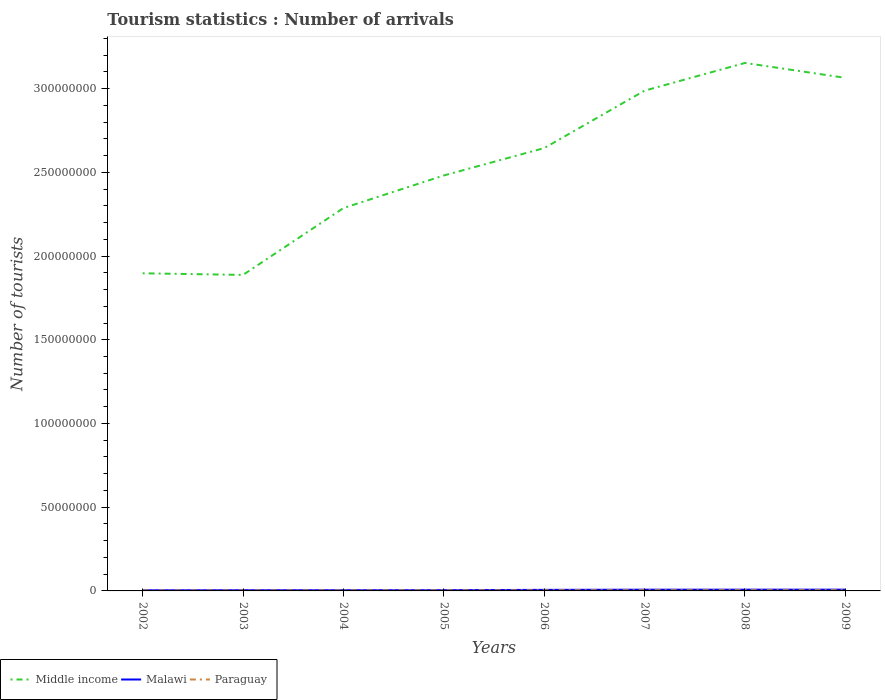Is the number of lines equal to the number of legend labels?
Keep it short and to the point. Yes. Across all years, what is the maximum number of tourist arrivals in Middle income?
Offer a very short reply. 1.89e+08. In which year was the number of tourist arrivals in Paraguay maximum?
Offer a terse response. 2002. What is the total number of tourist arrivals in Paraguay in the graph?
Offer a very short reply. -1.19e+05. What is the difference between the highest and the second highest number of tourist arrivals in Malawi?
Keep it short and to the point. 3.72e+05. What is the difference between the highest and the lowest number of tourist arrivals in Paraguay?
Keep it short and to the point. 4. How many years are there in the graph?
Keep it short and to the point. 8. What is the difference between two consecutive major ticks on the Y-axis?
Offer a terse response. 5.00e+07. Does the graph contain any zero values?
Ensure brevity in your answer.  No. Does the graph contain grids?
Give a very brief answer. No. Where does the legend appear in the graph?
Your answer should be compact. Bottom left. What is the title of the graph?
Provide a succinct answer. Tourism statistics : Number of arrivals. What is the label or title of the Y-axis?
Provide a short and direct response. Number of tourists. What is the Number of tourists in Middle income in 2002?
Your response must be concise. 1.90e+08. What is the Number of tourists of Malawi in 2002?
Make the answer very short. 3.83e+05. What is the Number of tourists of Paraguay in 2002?
Provide a short and direct response. 2.50e+05. What is the Number of tourists of Middle income in 2003?
Offer a terse response. 1.89e+08. What is the Number of tourists in Malawi in 2003?
Provide a short and direct response. 4.24e+05. What is the Number of tourists in Paraguay in 2003?
Ensure brevity in your answer.  2.68e+05. What is the Number of tourists of Middle income in 2004?
Provide a short and direct response. 2.29e+08. What is the Number of tourists of Malawi in 2004?
Keep it short and to the point. 4.27e+05. What is the Number of tourists of Paraguay in 2004?
Ensure brevity in your answer.  3.09e+05. What is the Number of tourists of Middle income in 2005?
Offer a terse response. 2.48e+08. What is the Number of tourists of Malawi in 2005?
Give a very brief answer. 4.38e+05. What is the Number of tourists in Paraguay in 2005?
Keep it short and to the point. 3.41e+05. What is the Number of tourists in Middle income in 2006?
Your answer should be compact. 2.64e+08. What is the Number of tourists of Malawi in 2006?
Provide a succinct answer. 6.38e+05. What is the Number of tourists of Paraguay in 2006?
Offer a terse response. 3.88e+05. What is the Number of tourists in Middle income in 2007?
Provide a succinct answer. 2.99e+08. What is the Number of tourists in Malawi in 2007?
Ensure brevity in your answer.  7.35e+05. What is the Number of tourists of Paraguay in 2007?
Give a very brief answer. 4.16e+05. What is the Number of tourists in Middle income in 2008?
Offer a very short reply. 3.15e+08. What is the Number of tourists of Malawi in 2008?
Keep it short and to the point. 7.42e+05. What is the Number of tourists in Paraguay in 2008?
Give a very brief answer. 4.28e+05. What is the Number of tourists of Middle income in 2009?
Your answer should be very brief. 3.06e+08. What is the Number of tourists in Malawi in 2009?
Offer a terse response. 7.55e+05. What is the Number of tourists in Paraguay in 2009?
Provide a short and direct response. 4.39e+05. Across all years, what is the maximum Number of tourists in Middle income?
Provide a succinct answer. 3.15e+08. Across all years, what is the maximum Number of tourists in Malawi?
Your response must be concise. 7.55e+05. Across all years, what is the maximum Number of tourists in Paraguay?
Your answer should be compact. 4.39e+05. Across all years, what is the minimum Number of tourists in Middle income?
Keep it short and to the point. 1.89e+08. Across all years, what is the minimum Number of tourists in Malawi?
Your answer should be very brief. 3.83e+05. What is the total Number of tourists of Middle income in the graph?
Provide a short and direct response. 2.04e+09. What is the total Number of tourists in Malawi in the graph?
Provide a short and direct response. 4.54e+06. What is the total Number of tourists of Paraguay in the graph?
Offer a very short reply. 2.84e+06. What is the difference between the Number of tourists in Middle income in 2002 and that in 2003?
Make the answer very short. 9.66e+05. What is the difference between the Number of tourists of Malawi in 2002 and that in 2003?
Give a very brief answer. -4.10e+04. What is the difference between the Number of tourists in Paraguay in 2002 and that in 2003?
Your answer should be compact. -1.80e+04. What is the difference between the Number of tourists in Middle income in 2002 and that in 2004?
Your answer should be compact. -3.90e+07. What is the difference between the Number of tourists in Malawi in 2002 and that in 2004?
Provide a short and direct response. -4.40e+04. What is the difference between the Number of tourists of Paraguay in 2002 and that in 2004?
Provide a short and direct response. -5.90e+04. What is the difference between the Number of tourists in Middle income in 2002 and that in 2005?
Keep it short and to the point. -5.84e+07. What is the difference between the Number of tourists in Malawi in 2002 and that in 2005?
Your answer should be compact. -5.50e+04. What is the difference between the Number of tourists of Paraguay in 2002 and that in 2005?
Ensure brevity in your answer.  -9.10e+04. What is the difference between the Number of tourists of Middle income in 2002 and that in 2006?
Your response must be concise. -7.48e+07. What is the difference between the Number of tourists of Malawi in 2002 and that in 2006?
Give a very brief answer. -2.55e+05. What is the difference between the Number of tourists of Paraguay in 2002 and that in 2006?
Your response must be concise. -1.38e+05. What is the difference between the Number of tourists of Middle income in 2002 and that in 2007?
Your response must be concise. -1.09e+08. What is the difference between the Number of tourists of Malawi in 2002 and that in 2007?
Offer a very short reply. -3.52e+05. What is the difference between the Number of tourists in Paraguay in 2002 and that in 2007?
Offer a very short reply. -1.66e+05. What is the difference between the Number of tourists of Middle income in 2002 and that in 2008?
Keep it short and to the point. -1.26e+08. What is the difference between the Number of tourists in Malawi in 2002 and that in 2008?
Your answer should be compact. -3.59e+05. What is the difference between the Number of tourists in Paraguay in 2002 and that in 2008?
Make the answer very short. -1.78e+05. What is the difference between the Number of tourists of Middle income in 2002 and that in 2009?
Give a very brief answer. -1.17e+08. What is the difference between the Number of tourists of Malawi in 2002 and that in 2009?
Ensure brevity in your answer.  -3.72e+05. What is the difference between the Number of tourists in Paraguay in 2002 and that in 2009?
Offer a very short reply. -1.89e+05. What is the difference between the Number of tourists in Middle income in 2003 and that in 2004?
Your answer should be very brief. -3.99e+07. What is the difference between the Number of tourists of Malawi in 2003 and that in 2004?
Offer a terse response. -3000. What is the difference between the Number of tourists in Paraguay in 2003 and that in 2004?
Your response must be concise. -4.10e+04. What is the difference between the Number of tourists of Middle income in 2003 and that in 2005?
Your response must be concise. -5.94e+07. What is the difference between the Number of tourists in Malawi in 2003 and that in 2005?
Give a very brief answer. -1.40e+04. What is the difference between the Number of tourists of Paraguay in 2003 and that in 2005?
Ensure brevity in your answer.  -7.30e+04. What is the difference between the Number of tourists of Middle income in 2003 and that in 2006?
Give a very brief answer. -7.57e+07. What is the difference between the Number of tourists in Malawi in 2003 and that in 2006?
Your answer should be very brief. -2.14e+05. What is the difference between the Number of tourists in Paraguay in 2003 and that in 2006?
Keep it short and to the point. -1.20e+05. What is the difference between the Number of tourists in Middle income in 2003 and that in 2007?
Ensure brevity in your answer.  -1.10e+08. What is the difference between the Number of tourists of Malawi in 2003 and that in 2007?
Provide a short and direct response. -3.11e+05. What is the difference between the Number of tourists of Paraguay in 2003 and that in 2007?
Make the answer very short. -1.48e+05. What is the difference between the Number of tourists in Middle income in 2003 and that in 2008?
Give a very brief answer. -1.27e+08. What is the difference between the Number of tourists in Malawi in 2003 and that in 2008?
Give a very brief answer. -3.18e+05. What is the difference between the Number of tourists in Paraguay in 2003 and that in 2008?
Keep it short and to the point. -1.60e+05. What is the difference between the Number of tourists of Middle income in 2003 and that in 2009?
Provide a succinct answer. -1.18e+08. What is the difference between the Number of tourists of Malawi in 2003 and that in 2009?
Offer a very short reply. -3.31e+05. What is the difference between the Number of tourists in Paraguay in 2003 and that in 2009?
Your answer should be compact. -1.71e+05. What is the difference between the Number of tourists in Middle income in 2004 and that in 2005?
Ensure brevity in your answer.  -1.95e+07. What is the difference between the Number of tourists of Malawi in 2004 and that in 2005?
Give a very brief answer. -1.10e+04. What is the difference between the Number of tourists of Paraguay in 2004 and that in 2005?
Make the answer very short. -3.20e+04. What is the difference between the Number of tourists of Middle income in 2004 and that in 2006?
Provide a short and direct response. -3.58e+07. What is the difference between the Number of tourists of Malawi in 2004 and that in 2006?
Your response must be concise. -2.11e+05. What is the difference between the Number of tourists in Paraguay in 2004 and that in 2006?
Your answer should be compact. -7.90e+04. What is the difference between the Number of tourists of Middle income in 2004 and that in 2007?
Provide a succinct answer. -7.01e+07. What is the difference between the Number of tourists in Malawi in 2004 and that in 2007?
Offer a terse response. -3.08e+05. What is the difference between the Number of tourists of Paraguay in 2004 and that in 2007?
Your response must be concise. -1.07e+05. What is the difference between the Number of tourists of Middle income in 2004 and that in 2008?
Ensure brevity in your answer.  -8.67e+07. What is the difference between the Number of tourists of Malawi in 2004 and that in 2008?
Provide a succinct answer. -3.15e+05. What is the difference between the Number of tourists of Paraguay in 2004 and that in 2008?
Offer a very short reply. -1.19e+05. What is the difference between the Number of tourists of Middle income in 2004 and that in 2009?
Your answer should be very brief. -7.78e+07. What is the difference between the Number of tourists of Malawi in 2004 and that in 2009?
Provide a succinct answer. -3.28e+05. What is the difference between the Number of tourists of Middle income in 2005 and that in 2006?
Offer a terse response. -1.64e+07. What is the difference between the Number of tourists of Paraguay in 2005 and that in 2006?
Your response must be concise. -4.70e+04. What is the difference between the Number of tourists of Middle income in 2005 and that in 2007?
Offer a very short reply. -5.07e+07. What is the difference between the Number of tourists in Malawi in 2005 and that in 2007?
Give a very brief answer. -2.97e+05. What is the difference between the Number of tourists in Paraguay in 2005 and that in 2007?
Your answer should be very brief. -7.50e+04. What is the difference between the Number of tourists in Middle income in 2005 and that in 2008?
Provide a succinct answer. -6.72e+07. What is the difference between the Number of tourists in Malawi in 2005 and that in 2008?
Offer a very short reply. -3.04e+05. What is the difference between the Number of tourists of Paraguay in 2005 and that in 2008?
Offer a terse response. -8.70e+04. What is the difference between the Number of tourists in Middle income in 2005 and that in 2009?
Make the answer very short. -5.83e+07. What is the difference between the Number of tourists in Malawi in 2005 and that in 2009?
Offer a very short reply. -3.17e+05. What is the difference between the Number of tourists of Paraguay in 2005 and that in 2009?
Give a very brief answer. -9.80e+04. What is the difference between the Number of tourists of Middle income in 2006 and that in 2007?
Make the answer very short. -3.43e+07. What is the difference between the Number of tourists in Malawi in 2006 and that in 2007?
Provide a succinct answer. -9.70e+04. What is the difference between the Number of tourists of Paraguay in 2006 and that in 2007?
Provide a short and direct response. -2.80e+04. What is the difference between the Number of tourists in Middle income in 2006 and that in 2008?
Your response must be concise. -5.08e+07. What is the difference between the Number of tourists of Malawi in 2006 and that in 2008?
Offer a very short reply. -1.04e+05. What is the difference between the Number of tourists of Paraguay in 2006 and that in 2008?
Offer a terse response. -4.00e+04. What is the difference between the Number of tourists in Middle income in 2006 and that in 2009?
Give a very brief answer. -4.19e+07. What is the difference between the Number of tourists in Malawi in 2006 and that in 2009?
Make the answer very short. -1.17e+05. What is the difference between the Number of tourists of Paraguay in 2006 and that in 2009?
Your answer should be very brief. -5.10e+04. What is the difference between the Number of tourists in Middle income in 2007 and that in 2008?
Your response must be concise. -1.65e+07. What is the difference between the Number of tourists in Malawi in 2007 and that in 2008?
Make the answer very short. -7000. What is the difference between the Number of tourists in Paraguay in 2007 and that in 2008?
Your answer should be very brief. -1.20e+04. What is the difference between the Number of tourists of Middle income in 2007 and that in 2009?
Provide a succinct answer. -7.64e+06. What is the difference between the Number of tourists of Malawi in 2007 and that in 2009?
Make the answer very short. -2.00e+04. What is the difference between the Number of tourists in Paraguay in 2007 and that in 2009?
Offer a terse response. -2.30e+04. What is the difference between the Number of tourists of Middle income in 2008 and that in 2009?
Give a very brief answer. 8.90e+06. What is the difference between the Number of tourists in Malawi in 2008 and that in 2009?
Give a very brief answer. -1.30e+04. What is the difference between the Number of tourists in Paraguay in 2008 and that in 2009?
Provide a short and direct response. -1.10e+04. What is the difference between the Number of tourists of Middle income in 2002 and the Number of tourists of Malawi in 2003?
Offer a terse response. 1.89e+08. What is the difference between the Number of tourists of Middle income in 2002 and the Number of tourists of Paraguay in 2003?
Make the answer very short. 1.89e+08. What is the difference between the Number of tourists of Malawi in 2002 and the Number of tourists of Paraguay in 2003?
Make the answer very short. 1.15e+05. What is the difference between the Number of tourists in Middle income in 2002 and the Number of tourists in Malawi in 2004?
Keep it short and to the point. 1.89e+08. What is the difference between the Number of tourists of Middle income in 2002 and the Number of tourists of Paraguay in 2004?
Keep it short and to the point. 1.89e+08. What is the difference between the Number of tourists in Malawi in 2002 and the Number of tourists in Paraguay in 2004?
Offer a terse response. 7.40e+04. What is the difference between the Number of tourists in Middle income in 2002 and the Number of tourists in Malawi in 2005?
Provide a succinct answer. 1.89e+08. What is the difference between the Number of tourists in Middle income in 2002 and the Number of tourists in Paraguay in 2005?
Your response must be concise. 1.89e+08. What is the difference between the Number of tourists in Malawi in 2002 and the Number of tourists in Paraguay in 2005?
Give a very brief answer. 4.20e+04. What is the difference between the Number of tourists of Middle income in 2002 and the Number of tourists of Malawi in 2006?
Offer a terse response. 1.89e+08. What is the difference between the Number of tourists of Middle income in 2002 and the Number of tourists of Paraguay in 2006?
Provide a short and direct response. 1.89e+08. What is the difference between the Number of tourists of Malawi in 2002 and the Number of tourists of Paraguay in 2006?
Offer a terse response. -5000. What is the difference between the Number of tourists of Middle income in 2002 and the Number of tourists of Malawi in 2007?
Offer a very short reply. 1.89e+08. What is the difference between the Number of tourists of Middle income in 2002 and the Number of tourists of Paraguay in 2007?
Your answer should be compact. 1.89e+08. What is the difference between the Number of tourists in Malawi in 2002 and the Number of tourists in Paraguay in 2007?
Ensure brevity in your answer.  -3.30e+04. What is the difference between the Number of tourists in Middle income in 2002 and the Number of tourists in Malawi in 2008?
Your response must be concise. 1.89e+08. What is the difference between the Number of tourists in Middle income in 2002 and the Number of tourists in Paraguay in 2008?
Keep it short and to the point. 1.89e+08. What is the difference between the Number of tourists in Malawi in 2002 and the Number of tourists in Paraguay in 2008?
Offer a very short reply. -4.50e+04. What is the difference between the Number of tourists in Middle income in 2002 and the Number of tourists in Malawi in 2009?
Provide a succinct answer. 1.89e+08. What is the difference between the Number of tourists of Middle income in 2002 and the Number of tourists of Paraguay in 2009?
Provide a succinct answer. 1.89e+08. What is the difference between the Number of tourists of Malawi in 2002 and the Number of tourists of Paraguay in 2009?
Provide a succinct answer. -5.60e+04. What is the difference between the Number of tourists in Middle income in 2003 and the Number of tourists in Malawi in 2004?
Provide a succinct answer. 1.88e+08. What is the difference between the Number of tourists of Middle income in 2003 and the Number of tourists of Paraguay in 2004?
Offer a very short reply. 1.88e+08. What is the difference between the Number of tourists of Malawi in 2003 and the Number of tourists of Paraguay in 2004?
Give a very brief answer. 1.15e+05. What is the difference between the Number of tourists of Middle income in 2003 and the Number of tourists of Malawi in 2005?
Give a very brief answer. 1.88e+08. What is the difference between the Number of tourists of Middle income in 2003 and the Number of tourists of Paraguay in 2005?
Ensure brevity in your answer.  1.88e+08. What is the difference between the Number of tourists of Malawi in 2003 and the Number of tourists of Paraguay in 2005?
Make the answer very short. 8.30e+04. What is the difference between the Number of tourists of Middle income in 2003 and the Number of tourists of Malawi in 2006?
Your answer should be very brief. 1.88e+08. What is the difference between the Number of tourists in Middle income in 2003 and the Number of tourists in Paraguay in 2006?
Provide a short and direct response. 1.88e+08. What is the difference between the Number of tourists in Malawi in 2003 and the Number of tourists in Paraguay in 2006?
Give a very brief answer. 3.60e+04. What is the difference between the Number of tourists of Middle income in 2003 and the Number of tourists of Malawi in 2007?
Your response must be concise. 1.88e+08. What is the difference between the Number of tourists in Middle income in 2003 and the Number of tourists in Paraguay in 2007?
Your answer should be very brief. 1.88e+08. What is the difference between the Number of tourists of Malawi in 2003 and the Number of tourists of Paraguay in 2007?
Offer a terse response. 8000. What is the difference between the Number of tourists of Middle income in 2003 and the Number of tourists of Malawi in 2008?
Your answer should be very brief. 1.88e+08. What is the difference between the Number of tourists in Middle income in 2003 and the Number of tourists in Paraguay in 2008?
Offer a very short reply. 1.88e+08. What is the difference between the Number of tourists of Malawi in 2003 and the Number of tourists of Paraguay in 2008?
Give a very brief answer. -4000. What is the difference between the Number of tourists of Middle income in 2003 and the Number of tourists of Malawi in 2009?
Offer a very short reply. 1.88e+08. What is the difference between the Number of tourists in Middle income in 2003 and the Number of tourists in Paraguay in 2009?
Provide a short and direct response. 1.88e+08. What is the difference between the Number of tourists of Malawi in 2003 and the Number of tourists of Paraguay in 2009?
Provide a short and direct response. -1.50e+04. What is the difference between the Number of tourists of Middle income in 2004 and the Number of tourists of Malawi in 2005?
Give a very brief answer. 2.28e+08. What is the difference between the Number of tourists in Middle income in 2004 and the Number of tourists in Paraguay in 2005?
Keep it short and to the point. 2.28e+08. What is the difference between the Number of tourists in Malawi in 2004 and the Number of tourists in Paraguay in 2005?
Keep it short and to the point. 8.60e+04. What is the difference between the Number of tourists of Middle income in 2004 and the Number of tourists of Malawi in 2006?
Your answer should be very brief. 2.28e+08. What is the difference between the Number of tourists in Middle income in 2004 and the Number of tourists in Paraguay in 2006?
Offer a very short reply. 2.28e+08. What is the difference between the Number of tourists of Malawi in 2004 and the Number of tourists of Paraguay in 2006?
Provide a short and direct response. 3.90e+04. What is the difference between the Number of tourists in Middle income in 2004 and the Number of tourists in Malawi in 2007?
Offer a very short reply. 2.28e+08. What is the difference between the Number of tourists in Middle income in 2004 and the Number of tourists in Paraguay in 2007?
Ensure brevity in your answer.  2.28e+08. What is the difference between the Number of tourists of Malawi in 2004 and the Number of tourists of Paraguay in 2007?
Offer a very short reply. 1.10e+04. What is the difference between the Number of tourists of Middle income in 2004 and the Number of tourists of Malawi in 2008?
Provide a succinct answer. 2.28e+08. What is the difference between the Number of tourists of Middle income in 2004 and the Number of tourists of Paraguay in 2008?
Give a very brief answer. 2.28e+08. What is the difference between the Number of tourists in Malawi in 2004 and the Number of tourists in Paraguay in 2008?
Ensure brevity in your answer.  -1000. What is the difference between the Number of tourists in Middle income in 2004 and the Number of tourists in Malawi in 2009?
Keep it short and to the point. 2.28e+08. What is the difference between the Number of tourists in Middle income in 2004 and the Number of tourists in Paraguay in 2009?
Your answer should be very brief. 2.28e+08. What is the difference between the Number of tourists in Malawi in 2004 and the Number of tourists in Paraguay in 2009?
Your answer should be compact. -1.20e+04. What is the difference between the Number of tourists in Middle income in 2005 and the Number of tourists in Malawi in 2006?
Provide a short and direct response. 2.47e+08. What is the difference between the Number of tourists in Middle income in 2005 and the Number of tourists in Paraguay in 2006?
Offer a very short reply. 2.48e+08. What is the difference between the Number of tourists of Malawi in 2005 and the Number of tourists of Paraguay in 2006?
Your answer should be very brief. 5.00e+04. What is the difference between the Number of tourists of Middle income in 2005 and the Number of tourists of Malawi in 2007?
Your response must be concise. 2.47e+08. What is the difference between the Number of tourists of Middle income in 2005 and the Number of tourists of Paraguay in 2007?
Offer a very short reply. 2.48e+08. What is the difference between the Number of tourists in Malawi in 2005 and the Number of tourists in Paraguay in 2007?
Provide a succinct answer. 2.20e+04. What is the difference between the Number of tourists of Middle income in 2005 and the Number of tourists of Malawi in 2008?
Keep it short and to the point. 2.47e+08. What is the difference between the Number of tourists in Middle income in 2005 and the Number of tourists in Paraguay in 2008?
Make the answer very short. 2.48e+08. What is the difference between the Number of tourists in Middle income in 2005 and the Number of tourists in Malawi in 2009?
Ensure brevity in your answer.  2.47e+08. What is the difference between the Number of tourists in Middle income in 2005 and the Number of tourists in Paraguay in 2009?
Your answer should be very brief. 2.48e+08. What is the difference between the Number of tourists of Malawi in 2005 and the Number of tourists of Paraguay in 2009?
Keep it short and to the point. -1000. What is the difference between the Number of tourists in Middle income in 2006 and the Number of tourists in Malawi in 2007?
Your response must be concise. 2.64e+08. What is the difference between the Number of tourists in Middle income in 2006 and the Number of tourists in Paraguay in 2007?
Provide a short and direct response. 2.64e+08. What is the difference between the Number of tourists in Malawi in 2006 and the Number of tourists in Paraguay in 2007?
Your answer should be very brief. 2.22e+05. What is the difference between the Number of tourists of Middle income in 2006 and the Number of tourists of Malawi in 2008?
Provide a short and direct response. 2.64e+08. What is the difference between the Number of tourists in Middle income in 2006 and the Number of tourists in Paraguay in 2008?
Your answer should be very brief. 2.64e+08. What is the difference between the Number of tourists of Malawi in 2006 and the Number of tourists of Paraguay in 2008?
Your answer should be very brief. 2.10e+05. What is the difference between the Number of tourists of Middle income in 2006 and the Number of tourists of Malawi in 2009?
Make the answer very short. 2.64e+08. What is the difference between the Number of tourists of Middle income in 2006 and the Number of tourists of Paraguay in 2009?
Offer a very short reply. 2.64e+08. What is the difference between the Number of tourists of Malawi in 2006 and the Number of tourists of Paraguay in 2009?
Offer a terse response. 1.99e+05. What is the difference between the Number of tourists of Middle income in 2007 and the Number of tourists of Malawi in 2008?
Offer a terse response. 2.98e+08. What is the difference between the Number of tourists in Middle income in 2007 and the Number of tourists in Paraguay in 2008?
Provide a succinct answer. 2.98e+08. What is the difference between the Number of tourists in Malawi in 2007 and the Number of tourists in Paraguay in 2008?
Give a very brief answer. 3.07e+05. What is the difference between the Number of tourists in Middle income in 2007 and the Number of tourists in Malawi in 2009?
Your answer should be very brief. 2.98e+08. What is the difference between the Number of tourists in Middle income in 2007 and the Number of tourists in Paraguay in 2009?
Offer a terse response. 2.98e+08. What is the difference between the Number of tourists in Malawi in 2007 and the Number of tourists in Paraguay in 2009?
Make the answer very short. 2.96e+05. What is the difference between the Number of tourists in Middle income in 2008 and the Number of tourists in Malawi in 2009?
Provide a short and direct response. 3.15e+08. What is the difference between the Number of tourists in Middle income in 2008 and the Number of tourists in Paraguay in 2009?
Provide a succinct answer. 3.15e+08. What is the difference between the Number of tourists in Malawi in 2008 and the Number of tourists in Paraguay in 2009?
Provide a short and direct response. 3.03e+05. What is the average Number of tourists of Middle income per year?
Provide a succinct answer. 2.55e+08. What is the average Number of tourists in Malawi per year?
Your answer should be very brief. 5.68e+05. What is the average Number of tourists in Paraguay per year?
Your answer should be compact. 3.55e+05. In the year 2002, what is the difference between the Number of tourists in Middle income and Number of tourists in Malawi?
Your answer should be compact. 1.89e+08. In the year 2002, what is the difference between the Number of tourists of Middle income and Number of tourists of Paraguay?
Give a very brief answer. 1.89e+08. In the year 2002, what is the difference between the Number of tourists of Malawi and Number of tourists of Paraguay?
Provide a succinct answer. 1.33e+05. In the year 2003, what is the difference between the Number of tourists in Middle income and Number of tourists in Malawi?
Your answer should be compact. 1.88e+08. In the year 2003, what is the difference between the Number of tourists of Middle income and Number of tourists of Paraguay?
Provide a short and direct response. 1.88e+08. In the year 2003, what is the difference between the Number of tourists in Malawi and Number of tourists in Paraguay?
Keep it short and to the point. 1.56e+05. In the year 2004, what is the difference between the Number of tourists in Middle income and Number of tourists in Malawi?
Ensure brevity in your answer.  2.28e+08. In the year 2004, what is the difference between the Number of tourists of Middle income and Number of tourists of Paraguay?
Make the answer very short. 2.28e+08. In the year 2004, what is the difference between the Number of tourists of Malawi and Number of tourists of Paraguay?
Your answer should be very brief. 1.18e+05. In the year 2005, what is the difference between the Number of tourists in Middle income and Number of tourists in Malawi?
Your answer should be compact. 2.48e+08. In the year 2005, what is the difference between the Number of tourists of Middle income and Number of tourists of Paraguay?
Give a very brief answer. 2.48e+08. In the year 2005, what is the difference between the Number of tourists in Malawi and Number of tourists in Paraguay?
Give a very brief answer. 9.70e+04. In the year 2006, what is the difference between the Number of tourists in Middle income and Number of tourists in Malawi?
Keep it short and to the point. 2.64e+08. In the year 2006, what is the difference between the Number of tourists in Middle income and Number of tourists in Paraguay?
Make the answer very short. 2.64e+08. In the year 2006, what is the difference between the Number of tourists in Malawi and Number of tourists in Paraguay?
Ensure brevity in your answer.  2.50e+05. In the year 2007, what is the difference between the Number of tourists of Middle income and Number of tourists of Malawi?
Your answer should be compact. 2.98e+08. In the year 2007, what is the difference between the Number of tourists of Middle income and Number of tourists of Paraguay?
Offer a very short reply. 2.98e+08. In the year 2007, what is the difference between the Number of tourists in Malawi and Number of tourists in Paraguay?
Provide a short and direct response. 3.19e+05. In the year 2008, what is the difference between the Number of tourists in Middle income and Number of tourists in Malawi?
Give a very brief answer. 3.15e+08. In the year 2008, what is the difference between the Number of tourists of Middle income and Number of tourists of Paraguay?
Offer a terse response. 3.15e+08. In the year 2008, what is the difference between the Number of tourists of Malawi and Number of tourists of Paraguay?
Your answer should be very brief. 3.14e+05. In the year 2009, what is the difference between the Number of tourists of Middle income and Number of tourists of Malawi?
Keep it short and to the point. 3.06e+08. In the year 2009, what is the difference between the Number of tourists of Middle income and Number of tourists of Paraguay?
Offer a terse response. 3.06e+08. In the year 2009, what is the difference between the Number of tourists of Malawi and Number of tourists of Paraguay?
Your answer should be very brief. 3.16e+05. What is the ratio of the Number of tourists of Middle income in 2002 to that in 2003?
Keep it short and to the point. 1.01. What is the ratio of the Number of tourists of Malawi in 2002 to that in 2003?
Give a very brief answer. 0.9. What is the ratio of the Number of tourists in Paraguay in 2002 to that in 2003?
Provide a short and direct response. 0.93. What is the ratio of the Number of tourists of Middle income in 2002 to that in 2004?
Provide a short and direct response. 0.83. What is the ratio of the Number of tourists of Malawi in 2002 to that in 2004?
Your response must be concise. 0.9. What is the ratio of the Number of tourists in Paraguay in 2002 to that in 2004?
Keep it short and to the point. 0.81. What is the ratio of the Number of tourists in Middle income in 2002 to that in 2005?
Offer a very short reply. 0.76. What is the ratio of the Number of tourists of Malawi in 2002 to that in 2005?
Your answer should be compact. 0.87. What is the ratio of the Number of tourists in Paraguay in 2002 to that in 2005?
Give a very brief answer. 0.73. What is the ratio of the Number of tourists of Middle income in 2002 to that in 2006?
Make the answer very short. 0.72. What is the ratio of the Number of tourists of Malawi in 2002 to that in 2006?
Keep it short and to the point. 0.6. What is the ratio of the Number of tourists in Paraguay in 2002 to that in 2006?
Keep it short and to the point. 0.64. What is the ratio of the Number of tourists in Middle income in 2002 to that in 2007?
Keep it short and to the point. 0.63. What is the ratio of the Number of tourists of Malawi in 2002 to that in 2007?
Your answer should be compact. 0.52. What is the ratio of the Number of tourists of Paraguay in 2002 to that in 2007?
Make the answer very short. 0.6. What is the ratio of the Number of tourists of Middle income in 2002 to that in 2008?
Your answer should be compact. 0.6. What is the ratio of the Number of tourists in Malawi in 2002 to that in 2008?
Offer a very short reply. 0.52. What is the ratio of the Number of tourists in Paraguay in 2002 to that in 2008?
Make the answer very short. 0.58. What is the ratio of the Number of tourists of Middle income in 2002 to that in 2009?
Offer a terse response. 0.62. What is the ratio of the Number of tourists in Malawi in 2002 to that in 2009?
Ensure brevity in your answer.  0.51. What is the ratio of the Number of tourists of Paraguay in 2002 to that in 2009?
Offer a terse response. 0.57. What is the ratio of the Number of tourists in Middle income in 2003 to that in 2004?
Your answer should be compact. 0.83. What is the ratio of the Number of tourists of Malawi in 2003 to that in 2004?
Your response must be concise. 0.99. What is the ratio of the Number of tourists of Paraguay in 2003 to that in 2004?
Offer a terse response. 0.87. What is the ratio of the Number of tourists of Middle income in 2003 to that in 2005?
Keep it short and to the point. 0.76. What is the ratio of the Number of tourists in Malawi in 2003 to that in 2005?
Your response must be concise. 0.97. What is the ratio of the Number of tourists in Paraguay in 2003 to that in 2005?
Ensure brevity in your answer.  0.79. What is the ratio of the Number of tourists in Middle income in 2003 to that in 2006?
Offer a very short reply. 0.71. What is the ratio of the Number of tourists in Malawi in 2003 to that in 2006?
Provide a succinct answer. 0.66. What is the ratio of the Number of tourists of Paraguay in 2003 to that in 2006?
Ensure brevity in your answer.  0.69. What is the ratio of the Number of tourists in Middle income in 2003 to that in 2007?
Provide a short and direct response. 0.63. What is the ratio of the Number of tourists in Malawi in 2003 to that in 2007?
Keep it short and to the point. 0.58. What is the ratio of the Number of tourists in Paraguay in 2003 to that in 2007?
Offer a very short reply. 0.64. What is the ratio of the Number of tourists of Middle income in 2003 to that in 2008?
Your answer should be very brief. 0.6. What is the ratio of the Number of tourists of Paraguay in 2003 to that in 2008?
Your response must be concise. 0.63. What is the ratio of the Number of tourists of Middle income in 2003 to that in 2009?
Your answer should be compact. 0.62. What is the ratio of the Number of tourists of Malawi in 2003 to that in 2009?
Give a very brief answer. 0.56. What is the ratio of the Number of tourists in Paraguay in 2003 to that in 2009?
Give a very brief answer. 0.61. What is the ratio of the Number of tourists in Middle income in 2004 to that in 2005?
Make the answer very short. 0.92. What is the ratio of the Number of tourists in Malawi in 2004 to that in 2005?
Your answer should be compact. 0.97. What is the ratio of the Number of tourists of Paraguay in 2004 to that in 2005?
Provide a short and direct response. 0.91. What is the ratio of the Number of tourists of Middle income in 2004 to that in 2006?
Give a very brief answer. 0.86. What is the ratio of the Number of tourists of Malawi in 2004 to that in 2006?
Your answer should be very brief. 0.67. What is the ratio of the Number of tourists in Paraguay in 2004 to that in 2006?
Your answer should be compact. 0.8. What is the ratio of the Number of tourists of Middle income in 2004 to that in 2007?
Your answer should be compact. 0.77. What is the ratio of the Number of tourists of Malawi in 2004 to that in 2007?
Make the answer very short. 0.58. What is the ratio of the Number of tourists of Paraguay in 2004 to that in 2007?
Ensure brevity in your answer.  0.74. What is the ratio of the Number of tourists in Middle income in 2004 to that in 2008?
Make the answer very short. 0.73. What is the ratio of the Number of tourists in Malawi in 2004 to that in 2008?
Your response must be concise. 0.58. What is the ratio of the Number of tourists in Paraguay in 2004 to that in 2008?
Your answer should be very brief. 0.72. What is the ratio of the Number of tourists in Middle income in 2004 to that in 2009?
Give a very brief answer. 0.75. What is the ratio of the Number of tourists in Malawi in 2004 to that in 2009?
Make the answer very short. 0.57. What is the ratio of the Number of tourists of Paraguay in 2004 to that in 2009?
Provide a short and direct response. 0.7. What is the ratio of the Number of tourists of Middle income in 2005 to that in 2006?
Make the answer very short. 0.94. What is the ratio of the Number of tourists of Malawi in 2005 to that in 2006?
Your answer should be very brief. 0.69. What is the ratio of the Number of tourists of Paraguay in 2005 to that in 2006?
Make the answer very short. 0.88. What is the ratio of the Number of tourists of Middle income in 2005 to that in 2007?
Your response must be concise. 0.83. What is the ratio of the Number of tourists in Malawi in 2005 to that in 2007?
Keep it short and to the point. 0.6. What is the ratio of the Number of tourists in Paraguay in 2005 to that in 2007?
Provide a short and direct response. 0.82. What is the ratio of the Number of tourists of Middle income in 2005 to that in 2008?
Offer a very short reply. 0.79. What is the ratio of the Number of tourists of Malawi in 2005 to that in 2008?
Your answer should be compact. 0.59. What is the ratio of the Number of tourists of Paraguay in 2005 to that in 2008?
Your answer should be very brief. 0.8. What is the ratio of the Number of tourists in Middle income in 2005 to that in 2009?
Keep it short and to the point. 0.81. What is the ratio of the Number of tourists of Malawi in 2005 to that in 2009?
Your response must be concise. 0.58. What is the ratio of the Number of tourists of Paraguay in 2005 to that in 2009?
Your response must be concise. 0.78. What is the ratio of the Number of tourists in Middle income in 2006 to that in 2007?
Your response must be concise. 0.89. What is the ratio of the Number of tourists in Malawi in 2006 to that in 2007?
Provide a short and direct response. 0.87. What is the ratio of the Number of tourists in Paraguay in 2006 to that in 2007?
Provide a short and direct response. 0.93. What is the ratio of the Number of tourists in Middle income in 2006 to that in 2008?
Provide a succinct answer. 0.84. What is the ratio of the Number of tourists in Malawi in 2006 to that in 2008?
Keep it short and to the point. 0.86. What is the ratio of the Number of tourists in Paraguay in 2006 to that in 2008?
Provide a short and direct response. 0.91. What is the ratio of the Number of tourists in Middle income in 2006 to that in 2009?
Provide a succinct answer. 0.86. What is the ratio of the Number of tourists in Malawi in 2006 to that in 2009?
Ensure brevity in your answer.  0.84. What is the ratio of the Number of tourists in Paraguay in 2006 to that in 2009?
Your answer should be very brief. 0.88. What is the ratio of the Number of tourists of Middle income in 2007 to that in 2008?
Offer a terse response. 0.95. What is the ratio of the Number of tourists of Malawi in 2007 to that in 2008?
Make the answer very short. 0.99. What is the ratio of the Number of tourists in Middle income in 2007 to that in 2009?
Your response must be concise. 0.98. What is the ratio of the Number of tourists in Malawi in 2007 to that in 2009?
Your answer should be very brief. 0.97. What is the ratio of the Number of tourists in Paraguay in 2007 to that in 2009?
Provide a short and direct response. 0.95. What is the ratio of the Number of tourists of Malawi in 2008 to that in 2009?
Your response must be concise. 0.98. What is the ratio of the Number of tourists of Paraguay in 2008 to that in 2009?
Your answer should be compact. 0.97. What is the difference between the highest and the second highest Number of tourists of Middle income?
Your answer should be very brief. 8.90e+06. What is the difference between the highest and the second highest Number of tourists of Malawi?
Provide a short and direct response. 1.30e+04. What is the difference between the highest and the second highest Number of tourists in Paraguay?
Keep it short and to the point. 1.10e+04. What is the difference between the highest and the lowest Number of tourists in Middle income?
Ensure brevity in your answer.  1.27e+08. What is the difference between the highest and the lowest Number of tourists of Malawi?
Your answer should be very brief. 3.72e+05. What is the difference between the highest and the lowest Number of tourists in Paraguay?
Your response must be concise. 1.89e+05. 